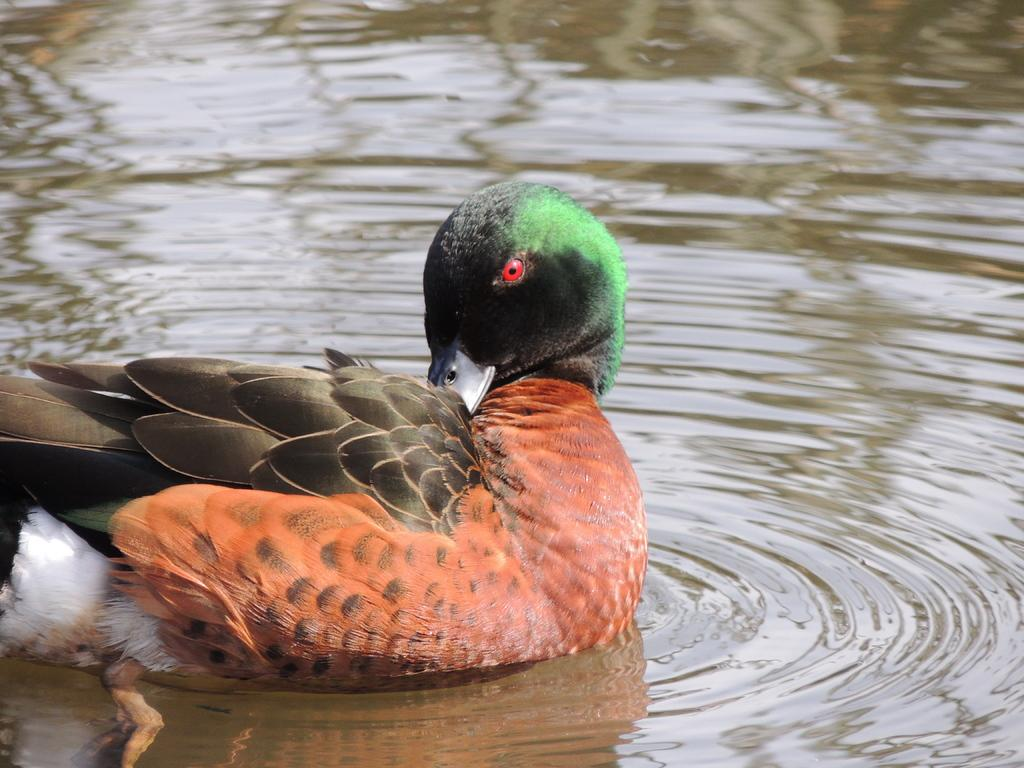What animal is present in the image? There is a duck in the image. Where is the duck located? The duck is in the water. What type of bridge can be seen in the image? There is no bridge present in the image; it features a duck in the water. What type of party is happening in the image? There is no party present in the image; it features a duck in the water. 